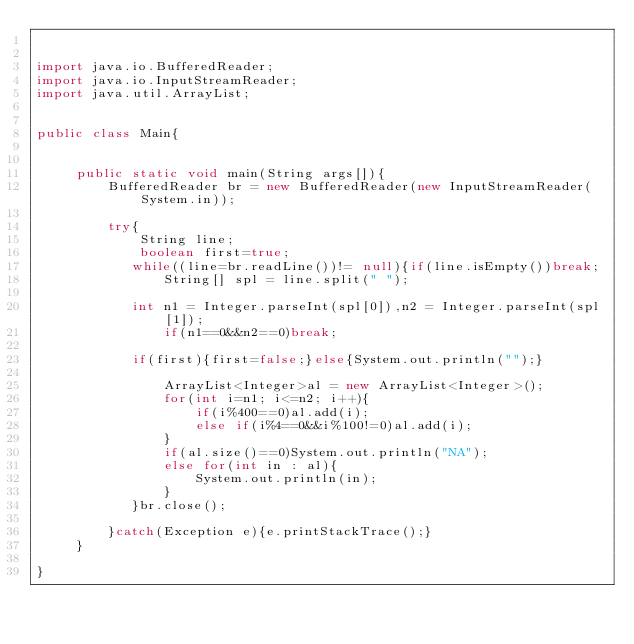<code> <loc_0><loc_0><loc_500><loc_500><_Java_>

import java.io.BufferedReader;
import java.io.InputStreamReader;
import java.util.ArrayList;
 

public class Main{
          
     
     public static void main(String args[]){
         BufferedReader br = new BufferedReader(new InputStreamReader(System.in));
         
         try{
             String line;
             boolean first=true;
            while((line=br.readLine())!= null){if(line.isEmpty())break;
                String[] spl = line.split(" ");
            
            int n1 = Integer.parseInt(spl[0]),n2 = Integer.parseInt(spl[1]);
                if(n1==0&&n2==0)break;
                    
            if(first){first=false;}else{System.out.println("");}
                
                ArrayList<Integer>al = new ArrayList<Integer>();
                for(int i=n1; i<=n2; i++){
                    if(i%400==0)al.add(i);
                    else if(i%4==0&&i%100!=0)al.add(i);
                }
                if(al.size()==0)System.out.println("NA");
                else for(int in : al){
                    System.out.println(in);
                }
            }br.close();
       
         }catch(Exception e){e.printStackTrace();}         
     }
     
}
  </code> 